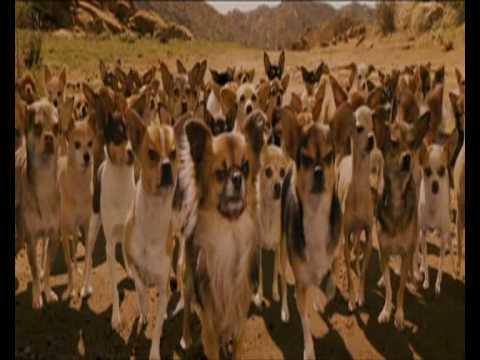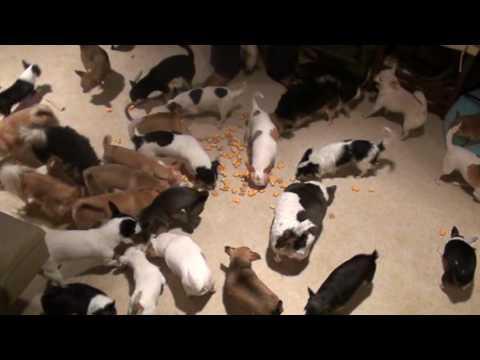The first image is the image on the left, the second image is the image on the right. For the images shown, is this caption "There are more than 10 dogs in the image on the left." true? Answer yes or no. Yes. 